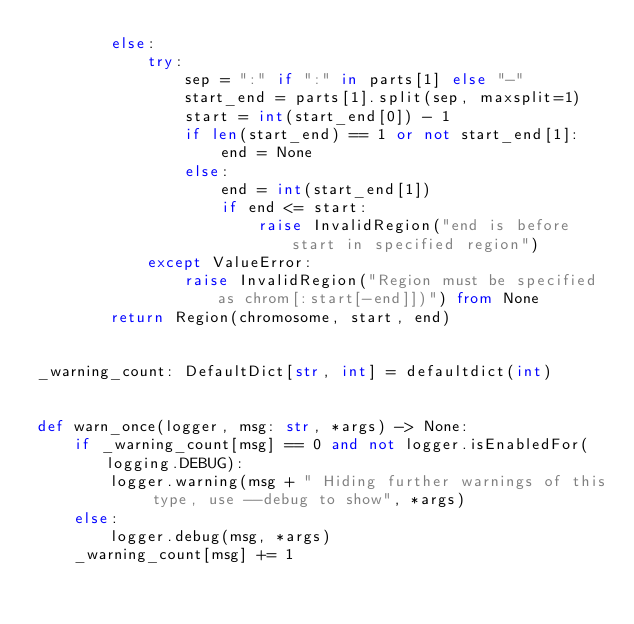<code> <loc_0><loc_0><loc_500><loc_500><_Python_>        else:
            try:
                sep = ":" if ":" in parts[1] else "-"
                start_end = parts[1].split(sep, maxsplit=1)
                start = int(start_end[0]) - 1
                if len(start_end) == 1 or not start_end[1]:
                    end = None
                else:
                    end = int(start_end[1])
                    if end <= start:
                        raise InvalidRegion("end is before start in specified region")
            except ValueError:
                raise InvalidRegion("Region must be specified as chrom[:start[-end]])") from None
        return Region(chromosome, start, end)


_warning_count: DefaultDict[str, int] = defaultdict(int)


def warn_once(logger, msg: str, *args) -> None:
    if _warning_count[msg] == 0 and not logger.isEnabledFor(logging.DEBUG):
        logger.warning(msg + " Hiding further warnings of this type, use --debug to show", *args)
    else:
        logger.debug(msg, *args)
    _warning_count[msg] += 1
</code> 